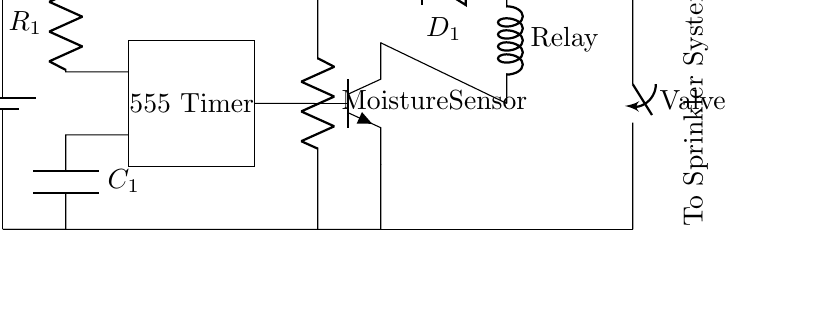What is the voltage of this circuit? The voltage source is labeled as 12V, indicating the potential difference supplied to the circuit.
Answer: 12V What component is used as a timing device? The circuit diagram clearly shows a rectangle labeled "555 Timer", indicating that the timing functionality is provided by the 555 timer integrated circuit.
Answer: 555 Timer How many resistors are in the circuit? There is one resistor labeled as "R1" in the circuit diagram, which is connected to the 555 Timer, confirming the count.
Answer: 1 What is the role of the moisture sensor in the circuit? The moisture sensor is depicted as a resistor in the circuit diagram, and it likely serves to detect soil moisture levels, which contributes to the irrigation control logic.
Answer: Soil detection What happens when the moisture sensor detects dry soil? Based on the design of the circuit, if the moisture sensor detects dry soil, it allows the timer to activate the relay and open the valve, allowing water to flow.
Answer: Activates irrigation What type of transistor is used in this circuit? The diagram shows a symbol for an NPN transistor, indicating that it is an NPN type used to control the relay in the irrigation system.
Answer: NPN What component is used to protect against back emf? The circuit includes a diode labeled "D1" connected across the relay, which is used to protect the circuit from the back electromotive force generated when the relay coil is de-energized.
Answer: Diode 